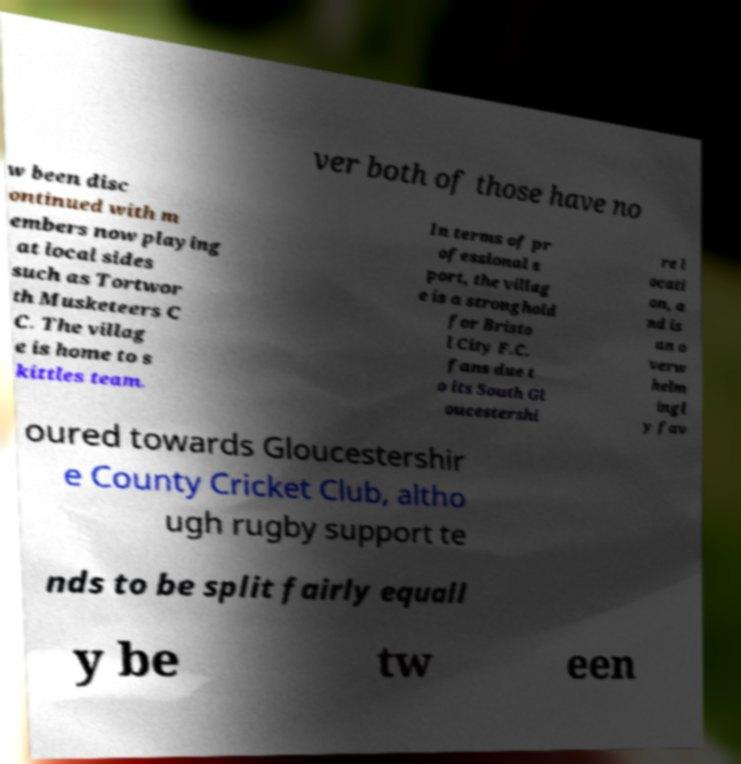What messages or text are displayed in this image? I need them in a readable, typed format. ver both of those have no w been disc ontinued with m embers now playing at local sides such as Tortwor th Musketeers C C. The villag e is home to s kittles team. In terms of pr ofessional s port, the villag e is a stronghold for Bristo l City F.C. fans due t o its South Gl oucestershi re l ocati on, a nd is an o verw helm ingl y fav oured towards Gloucestershir e County Cricket Club, altho ugh rugby support te nds to be split fairly equall y be tw een 